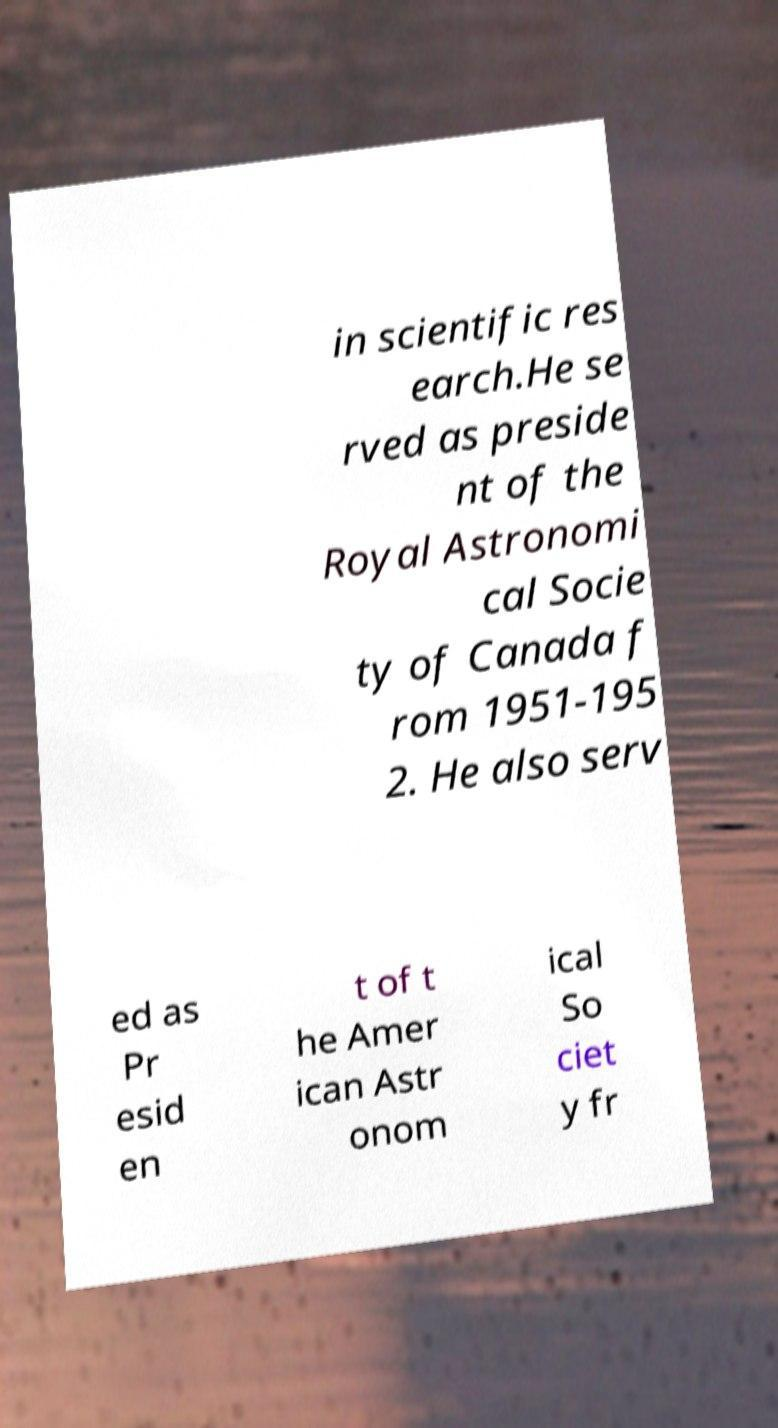Can you read and provide the text displayed in the image?This photo seems to have some interesting text. Can you extract and type it out for me? in scientific res earch.He se rved as preside nt of the Royal Astronomi cal Socie ty of Canada f rom 1951-195 2. He also serv ed as Pr esid en t of t he Amer ican Astr onom ical So ciet y fr 